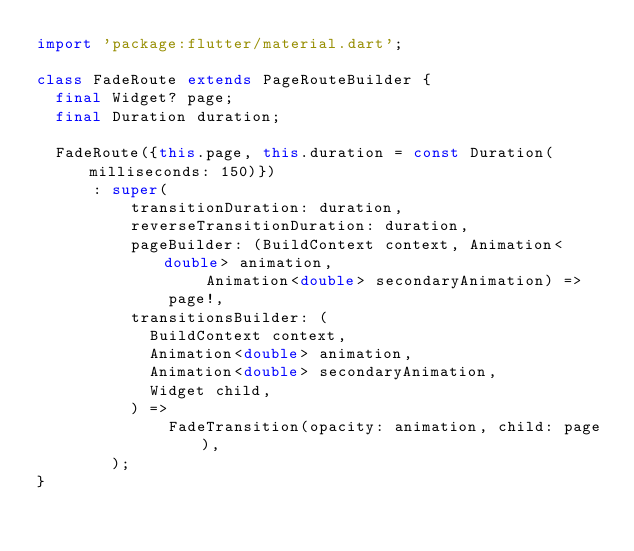Convert code to text. <code><loc_0><loc_0><loc_500><loc_500><_Dart_>import 'package:flutter/material.dart';

class FadeRoute extends PageRouteBuilder {
  final Widget? page;
  final Duration duration;

  FadeRoute({this.page, this.duration = const Duration(milliseconds: 150)})
      : super(
          transitionDuration: duration,
          reverseTransitionDuration: duration,
          pageBuilder: (BuildContext context, Animation<double> animation,
                  Animation<double> secondaryAnimation) =>
              page!,
          transitionsBuilder: (
            BuildContext context,
            Animation<double> animation,
            Animation<double> secondaryAnimation,
            Widget child,
          ) =>
              FadeTransition(opacity: animation, child: page),
        );
}
</code> 